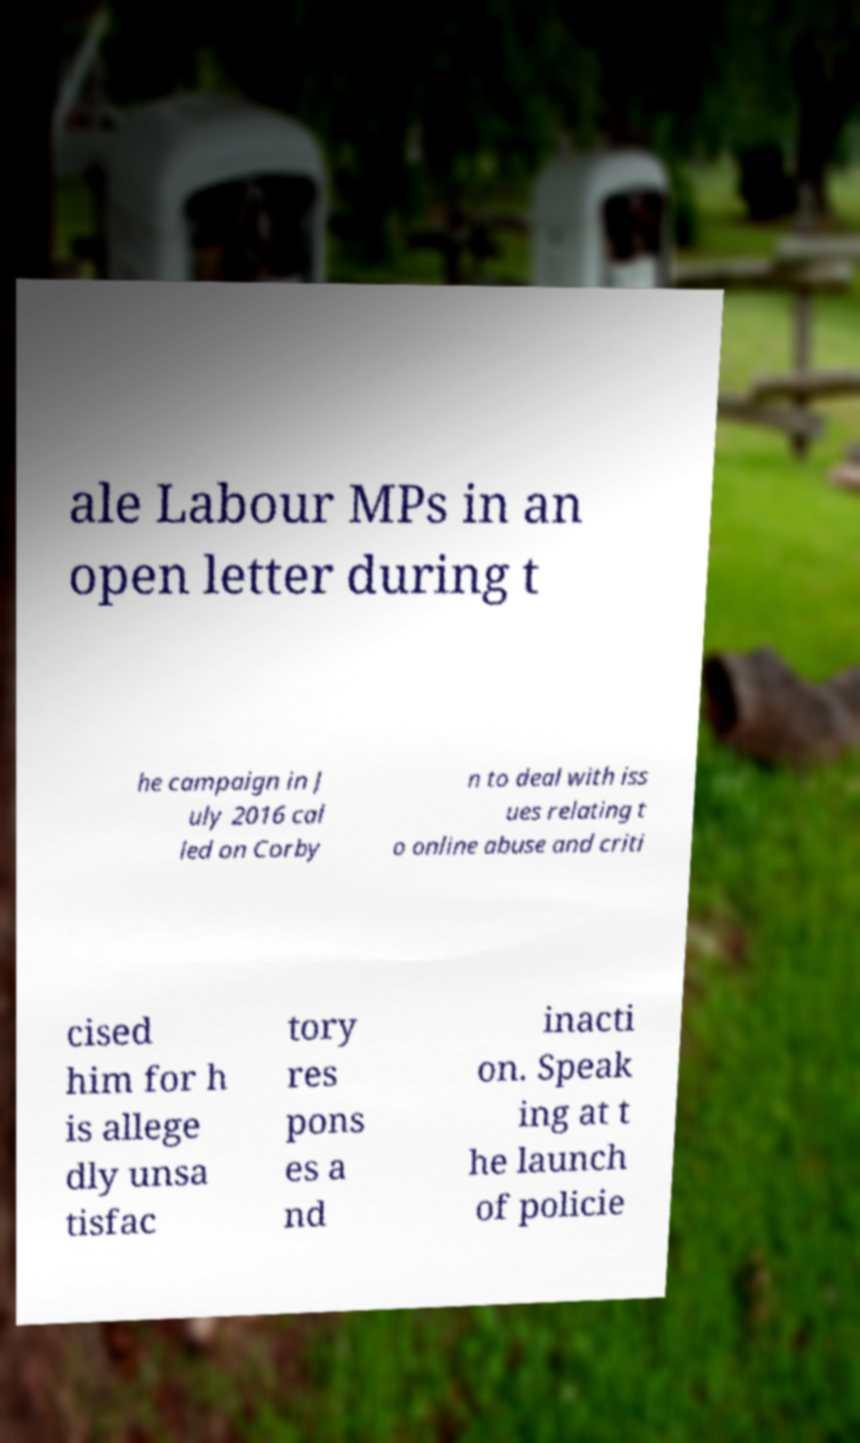There's text embedded in this image that I need extracted. Can you transcribe it verbatim? ale Labour MPs in an open letter during t he campaign in J uly 2016 cal led on Corby n to deal with iss ues relating t o online abuse and criti cised him for h is allege dly unsa tisfac tory res pons es a nd inacti on. Speak ing at t he launch of policie 